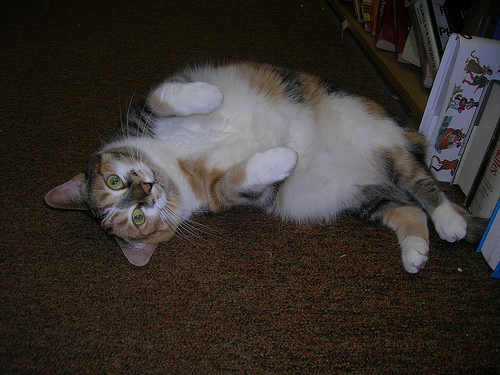<image>
Is there a cat to the right of the floor? No. The cat is not to the right of the floor. The horizontal positioning shows a different relationship. 